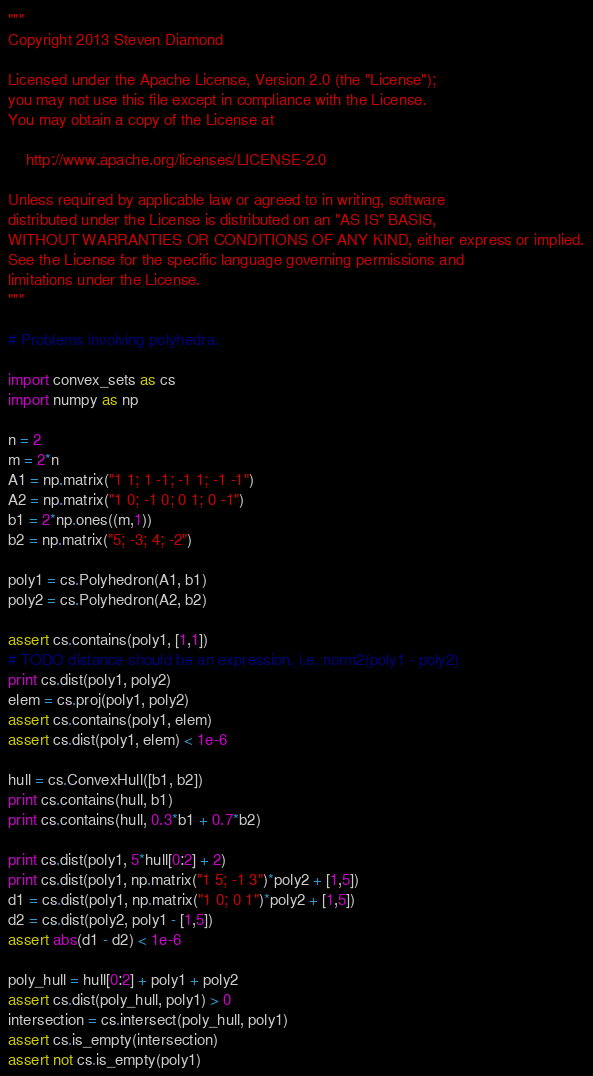Convert code to text. <code><loc_0><loc_0><loc_500><loc_500><_Python_>"""
Copyright 2013 Steven Diamond

Licensed under the Apache License, Version 2.0 (the "License");
you may not use this file except in compliance with the License.
You may obtain a copy of the License at

    http://www.apache.org/licenses/LICENSE-2.0

Unless required by applicable law or agreed to in writing, software
distributed under the License is distributed on an "AS IS" BASIS,
WITHOUT WARRANTIES OR CONDITIONS OF ANY KIND, either express or implied.
See the License for the specific language governing permissions and
limitations under the License.
"""

# Problems involving polyhedra.

import convex_sets as cs
import numpy as np

n = 2
m = 2*n
A1 = np.matrix("1 1; 1 -1; -1 1; -1 -1")
A2 = np.matrix("1 0; -1 0; 0 1; 0 -1")
b1 = 2*np.ones((m,1))
b2 = np.matrix("5; -3; 4; -2")

poly1 = cs.Polyhedron(A1, b1)
poly2 = cs.Polyhedron(A2, b2)

assert cs.contains(poly1, [1,1])
# TODO distance should be an expression, i.e. norm2(poly1 - poly2)
print cs.dist(poly1, poly2)
elem = cs.proj(poly1, poly2)
assert cs.contains(poly1, elem)
assert cs.dist(poly1, elem) < 1e-6

hull = cs.ConvexHull([b1, b2])
print cs.contains(hull, b1)
print cs.contains(hull, 0.3*b1 + 0.7*b2)

print cs.dist(poly1, 5*hull[0:2] + 2)
print cs.dist(poly1, np.matrix("1 5; -1 3")*poly2 + [1,5])
d1 = cs.dist(poly1, np.matrix("1 0; 0 1")*poly2 + [1,5])
d2 = cs.dist(poly2, poly1 - [1,5])
assert abs(d1 - d2) < 1e-6

poly_hull = hull[0:2] + poly1 + poly2
assert cs.dist(poly_hull, poly1) > 0
intersection = cs.intersect(poly_hull, poly1)
assert cs.is_empty(intersection)
assert not cs.is_empty(poly1)
</code> 